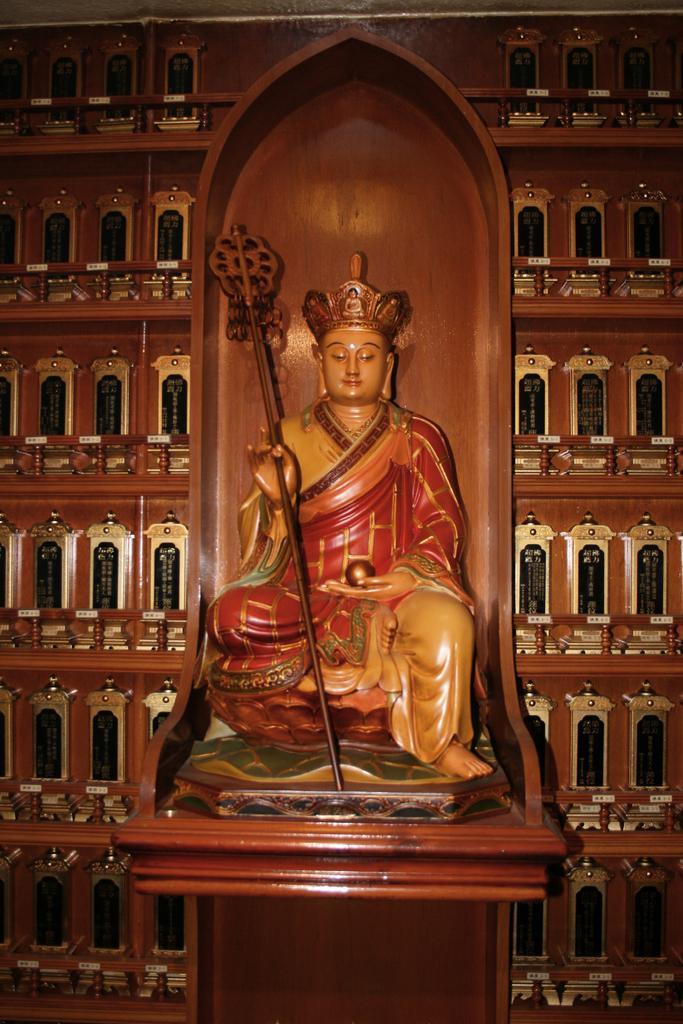Describe this image in one or two sentences. In this image we can see a sculpture of a person holding a stick and a ball, behind it, there is a wall, there might be windows on it. 